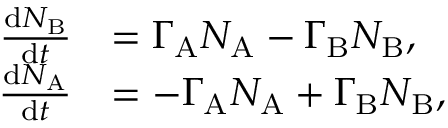Convert formula to latex. <formula><loc_0><loc_0><loc_500><loc_500>\begin{array} { r l } { \frac { d N _ { B } } { d t } } & { = \Gamma _ { A } N _ { A } - \Gamma _ { B } N _ { B } , } \\ { \frac { d N _ { A } } { d t } } & { = - \Gamma _ { A } N _ { A } + \Gamma _ { B } N _ { B } , } \end{array}</formula> 